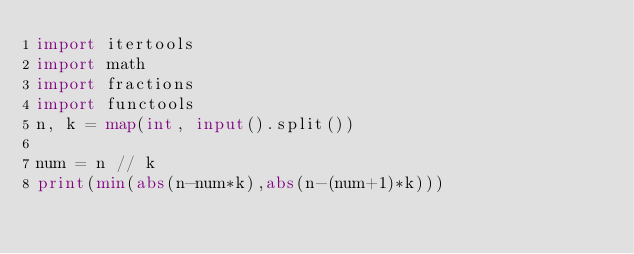Convert code to text. <code><loc_0><loc_0><loc_500><loc_500><_Python_>import itertools
import math
import fractions
import functools
n, k = map(int, input().split())

num = n // k
print(min(abs(n-num*k),abs(n-(num+1)*k)))</code> 